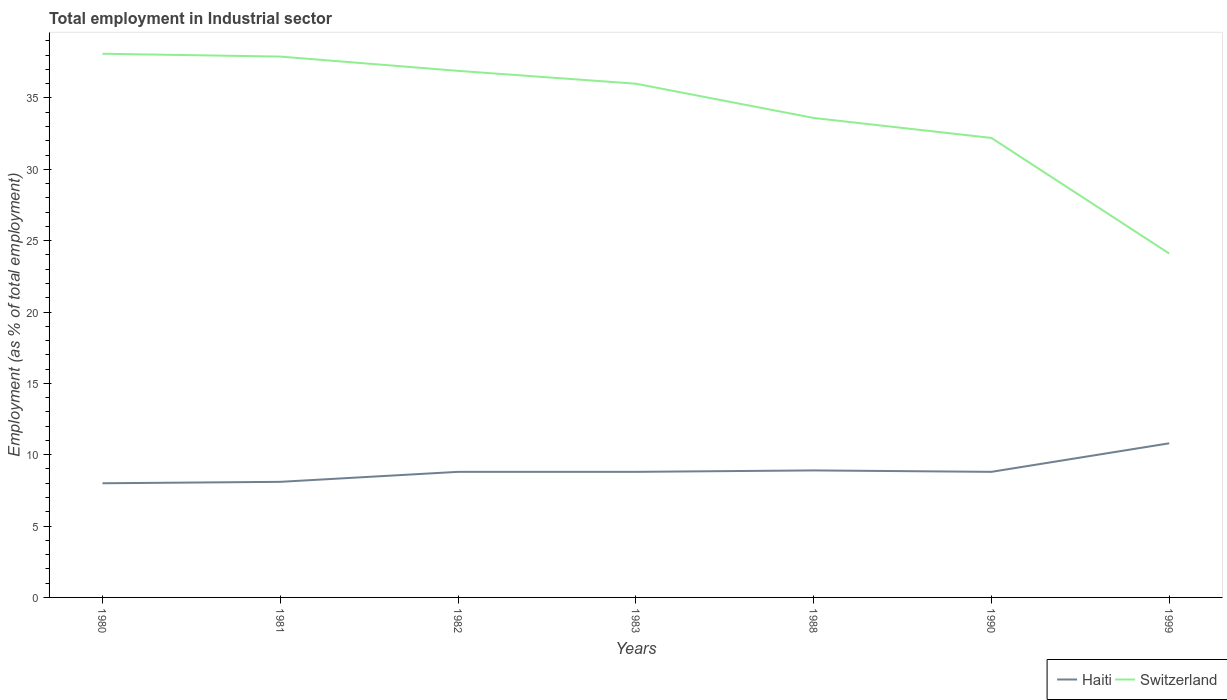Does the line corresponding to Haiti intersect with the line corresponding to Switzerland?
Provide a succinct answer. No. Is the number of lines equal to the number of legend labels?
Offer a very short reply. Yes. Across all years, what is the maximum employment in industrial sector in Switzerland?
Provide a succinct answer. 24.1. In which year was the employment in industrial sector in Haiti maximum?
Provide a short and direct response. 1980. What is the total employment in industrial sector in Haiti in the graph?
Your response must be concise. -0.1. What is the difference between the highest and the second highest employment in industrial sector in Switzerland?
Offer a very short reply. 14. Is the employment in industrial sector in Switzerland strictly greater than the employment in industrial sector in Haiti over the years?
Offer a very short reply. No. How many years are there in the graph?
Your answer should be very brief. 7. Does the graph contain any zero values?
Keep it short and to the point. No. Does the graph contain grids?
Provide a succinct answer. No. How many legend labels are there?
Your answer should be very brief. 2. What is the title of the graph?
Give a very brief answer. Total employment in Industrial sector. Does "Cameroon" appear as one of the legend labels in the graph?
Offer a terse response. No. What is the label or title of the X-axis?
Your answer should be very brief. Years. What is the label or title of the Y-axis?
Offer a very short reply. Employment (as % of total employment). What is the Employment (as % of total employment) of Haiti in 1980?
Keep it short and to the point. 8. What is the Employment (as % of total employment) in Switzerland in 1980?
Your answer should be very brief. 38.1. What is the Employment (as % of total employment) in Haiti in 1981?
Your response must be concise. 8.1. What is the Employment (as % of total employment) in Switzerland in 1981?
Offer a terse response. 37.9. What is the Employment (as % of total employment) of Haiti in 1982?
Give a very brief answer. 8.8. What is the Employment (as % of total employment) in Switzerland in 1982?
Your answer should be compact. 36.9. What is the Employment (as % of total employment) in Haiti in 1983?
Provide a short and direct response. 8.8. What is the Employment (as % of total employment) of Haiti in 1988?
Your response must be concise. 8.9. What is the Employment (as % of total employment) of Switzerland in 1988?
Offer a terse response. 33.6. What is the Employment (as % of total employment) of Haiti in 1990?
Keep it short and to the point. 8.8. What is the Employment (as % of total employment) of Switzerland in 1990?
Give a very brief answer. 32.2. What is the Employment (as % of total employment) of Haiti in 1999?
Offer a terse response. 10.8. What is the Employment (as % of total employment) of Switzerland in 1999?
Provide a short and direct response. 24.1. Across all years, what is the maximum Employment (as % of total employment) in Haiti?
Keep it short and to the point. 10.8. Across all years, what is the maximum Employment (as % of total employment) in Switzerland?
Provide a succinct answer. 38.1. Across all years, what is the minimum Employment (as % of total employment) in Switzerland?
Provide a succinct answer. 24.1. What is the total Employment (as % of total employment) in Haiti in the graph?
Provide a succinct answer. 62.2. What is the total Employment (as % of total employment) in Switzerland in the graph?
Keep it short and to the point. 238.8. What is the difference between the Employment (as % of total employment) in Haiti in 1980 and that in 1983?
Give a very brief answer. -0.8. What is the difference between the Employment (as % of total employment) of Haiti in 1980 and that in 1990?
Provide a short and direct response. -0.8. What is the difference between the Employment (as % of total employment) of Haiti in 1980 and that in 1999?
Provide a short and direct response. -2.8. What is the difference between the Employment (as % of total employment) of Haiti in 1981 and that in 1982?
Make the answer very short. -0.7. What is the difference between the Employment (as % of total employment) in Switzerland in 1981 and that in 1983?
Provide a short and direct response. 1.9. What is the difference between the Employment (as % of total employment) of Haiti in 1981 and that in 1988?
Provide a succinct answer. -0.8. What is the difference between the Employment (as % of total employment) in Switzerland in 1981 and that in 1999?
Your answer should be very brief. 13.8. What is the difference between the Employment (as % of total employment) of Haiti in 1982 and that in 1983?
Your response must be concise. 0. What is the difference between the Employment (as % of total employment) of Switzerland in 1982 and that in 1983?
Your answer should be compact. 0.9. What is the difference between the Employment (as % of total employment) of Switzerland in 1982 and that in 1988?
Your answer should be compact. 3.3. What is the difference between the Employment (as % of total employment) in Haiti in 1982 and that in 1990?
Provide a succinct answer. 0. What is the difference between the Employment (as % of total employment) in Switzerland in 1982 and that in 1990?
Your response must be concise. 4.7. What is the difference between the Employment (as % of total employment) in Switzerland in 1982 and that in 1999?
Provide a succinct answer. 12.8. What is the difference between the Employment (as % of total employment) of Haiti in 1983 and that in 1988?
Give a very brief answer. -0.1. What is the difference between the Employment (as % of total employment) of Switzerland in 1983 and that in 1988?
Provide a short and direct response. 2.4. What is the difference between the Employment (as % of total employment) of Haiti in 1983 and that in 1990?
Give a very brief answer. 0. What is the difference between the Employment (as % of total employment) in Haiti in 1983 and that in 1999?
Offer a terse response. -2. What is the difference between the Employment (as % of total employment) in Switzerland in 1988 and that in 1990?
Give a very brief answer. 1.4. What is the difference between the Employment (as % of total employment) in Haiti in 1988 and that in 1999?
Keep it short and to the point. -1.9. What is the difference between the Employment (as % of total employment) in Switzerland in 1990 and that in 1999?
Ensure brevity in your answer.  8.1. What is the difference between the Employment (as % of total employment) in Haiti in 1980 and the Employment (as % of total employment) in Switzerland in 1981?
Provide a short and direct response. -29.9. What is the difference between the Employment (as % of total employment) in Haiti in 1980 and the Employment (as % of total employment) in Switzerland in 1982?
Offer a terse response. -28.9. What is the difference between the Employment (as % of total employment) in Haiti in 1980 and the Employment (as % of total employment) in Switzerland in 1983?
Make the answer very short. -28. What is the difference between the Employment (as % of total employment) in Haiti in 1980 and the Employment (as % of total employment) in Switzerland in 1988?
Provide a succinct answer. -25.6. What is the difference between the Employment (as % of total employment) of Haiti in 1980 and the Employment (as % of total employment) of Switzerland in 1990?
Offer a terse response. -24.2. What is the difference between the Employment (as % of total employment) in Haiti in 1980 and the Employment (as % of total employment) in Switzerland in 1999?
Provide a short and direct response. -16.1. What is the difference between the Employment (as % of total employment) in Haiti in 1981 and the Employment (as % of total employment) in Switzerland in 1982?
Provide a short and direct response. -28.8. What is the difference between the Employment (as % of total employment) in Haiti in 1981 and the Employment (as % of total employment) in Switzerland in 1983?
Your response must be concise. -27.9. What is the difference between the Employment (as % of total employment) in Haiti in 1981 and the Employment (as % of total employment) in Switzerland in 1988?
Provide a succinct answer. -25.5. What is the difference between the Employment (as % of total employment) in Haiti in 1981 and the Employment (as % of total employment) in Switzerland in 1990?
Make the answer very short. -24.1. What is the difference between the Employment (as % of total employment) in Haiti in 1981 and the Employment (as % of total employment) in Switzerland in 1999?
Give a very brief answer. -16. What is the difference between the Employment (as % of total employment) in Haiti in 1982 and the Employment (as % of total employment) in Switzerland in 1983?
Offer a very short reply. -27.2. What is the difference between the Employment (as % of total employment) of Haiti in 1982 and the Employment (as % of total employment) of Switzerland in 1988?
Your answer should be very brief. -24.8. What is the difference between the Employment (as % of total employment) in Haiti in 1982 and the Employment (as % of total employment) in Switzerland in 1990?
Provide a short and direct response. -23.4. What is the difference between the Employment (as % of total employment) of Haiti in 1982 and the Employment (as % of total employment) of Switzerland in 1999?
Your response must be concise. -15.3. What is the difference between the Employment (as % of total employment) of Haiti in 1983 and the Employment (as % of total employment) of Switzerland in 1988?
Offer a very short reply. -24.8. What is the difference between the Employment (as % of total employment) in Haiti in 1983 and the Employment (as % of total employment) in Switzerland in 1990?
Your answer should be compact. -23.4. What is the difference between the Employment (as % of total employment) in Haiti in 1983 and the Employment (as % of total employment) in Switzerland in 1999?
Ensure brevity in your answer.  -15.3. What is the difference between the Employment (as % of total employment) of Haiti in 1988 and the Employment (as % of total employment) of Switzerland in 1990?
Provide a short and direct response. -23.3. What is the difference between the Employment (as % of total employment) in Haiti in 1988 and the Employment (as % of total employment) in Switzerland in 1999?
Provide a short and direct response. -15.2. What is the difference between the Employment (as % of total employment) of Haiti in 1990 and the Employment (as % of total employment) of Switzerland in 1999?
Your response must be concise. -15.3. What is the average Employment (as % of total employment) in Haiti per year?
Offer a terse response. 8.89. What is the average Employment (as % of total employment) in Switzerland per year?
Provide a succinct answer. 34.11. In the year 1980, what is the difference between the Employment (as % of total employment) in Haiti and Employment (as % of total employment) in Switzerland?
Your response must be concise. -30.1. In the year 1981, what is the difference between the Employment (as % of total employment) of Haiti and Employment (as % of total employment) of Switzerland?
Keep it short and to the point. -29.8. In the year 1982, what is the difference between the Employment (as % of total employment) of Haiti and Employment (as % of total employment) of Switzerland?
Offer a very short reply. -28.1. In the year 1983, what is the difference between the Employment (as % of total employment) in Haiti and Employment (as % of total employment) in Switzerland?
Give a very brief answer. -27.2. In the year 1988, what is the difference between the Employment (as % of total employment) of Haiti and Employment (as % of total employment) of Switzerland?
Offer a terse response. -24.7. In the year 1990, what is the difference between the Employment (as % of total employment) of Haiti and Employment (as % of total employment) of Switzerland?
Ensure brevity in your answer.  -23.4. What is the ratio of the Employment (as % of total employment) of Switzerland in 1980 to that in 1981?
Your answer should be compact. 1.01. What is the ratio of the Employment (as % of total employment) of Switzerland in 1980 to that in 1982?
Provide a short and direct response. 1.03. What is the ratio of the Employment (as % of total employment) of Switzerland in 1980 to that in 1983?
Give a very brief answer. 1.06. What is the ratio of the Employment (as % of total employment) of Haiti in 1980 to that in 1988?
Provide a succinct answer. 0.9. What is the ratio of the Employment (as % of total employment) of Switzerland in 1980 to that in 1988?
Provide a short and direct response. 1.13. What is the ratio of the Employment (as % of total employment) of Switzerland in 1980 to that in 1990?
Keep it short and to the point. 1.18. What is the ratio of the Employment (as % of total employment) in Haiti in 1980 to that in 1999?
Your response must be concise. 0.74. What is the ratio of the Employment (as % of total employment) in Switzerland in 1980 to that in 1999?
Your answer should be compact. 1.58. What is the ratio of the Employment (as % of total employment) of Haiti in 1981 to that in 1982?
Ensure brevity in your answer.  0.92. What is the ratio of the Employment (as % of total employment) of Switzerland in 1981 to that in 1982?
Provide a short and direct response. 1.03. What is the ratio of the Employment (as % of total employment) in Haiti in 1981 to that in 1983?
Ensure brevity in your answer.  0.92. What is the ratio of the Employment (as % of total employment) of Switzerland in 1981 to that in 1983?
Make the answer very short. 1.05. What is the ratio of the Employment (as % of total employment) in Haiti in 1981 to that in 1988?
Offer a terse response. 0.91. What is the ratio of the Employment (as % of total employment) of Switzerland in 1981 to that in 1988?
Give a very brief answer. 1.13. What is the ratio of the Employment (as % of total employment) of Haiti in 1981 to that in 1990?
Ensure brevity in your answer.  0.92. What is the ratio of the Employment (as % of total employment) in Switzerland in 1981 to that in 1990?
Provide a short and direct response. 1.18. What is the ratio of the Employment (as % of total employment) of Switzerland in 1981 to that in 1999?
Provide a short and direct response. 1.57. What is the ratio of the Employment (as % of total employment) of Haiti in 1982 to that in 1983?
Your answer should be compact. 1. What is the ratio of the Employment (as % of total employment) of Haiti in 1982 to that in 1988?
Offer a terse response. 0.99. What is the ratio of the Employment (as % of total employment) of Switzerland in 1982 to that in 1988?
Your answer should be compact. 1.1. What is the ratio of the Employment (as % of total employment) in Switzerland in 1982 to that in 1990?
Provide a short and direct response. 1.15. What is the ratio of the Employment (as % of total employment) of Haiti in 1982 to that in 1999?
Provide a short and direct response. 0.81. What is the ratio of the Employment (as % of total employment) of Switzerland in 1982 to that in 1999?
Make the answer very short. 1.53. What is the ratio of the Employment (as % of total employment) in Switzerland in 1983 to that in 1988?
Keep it short and to the point. 1.07. What is the ratio of the Employment (as % of total employment) of Haiti in 1983 to that in 1990?
Make the answer very short. 1. What is the ratio of the Employment (as % of total employment) in Switzerland in 1983 to that in 1990?
Provide a short and direct response. 1.12. What is the ratio of the Employment (as % of total employment) of Haiti in 1983 to that in 1999?
Offer a terse response. 0.81. What is the ratio of the Employment (as % of total employment) in Switzerland in 1983 to that in 1999?
Keep it short and to the point. 1.49. What is the ratio of the Employment (as % of total employment) of Haiti in 1988 to that in 1990?
Offer a very short reply. 1.01. What is the ratio of the Employment (as % of total employment) in Switzerland in 1988 to that in 1990?
Offer a terse response. 1.04. What is the ratio of the Employment (as % of total employment) of Haiti in 1988 to that in 1999?
Make the answer very short. 0.82. What is the ratio of the Employment (as % of total employment) of Switzerland in 1988 to that in 1999?
Keep it short and to the point. 1.39. What is the ratio of the Employment (as % of total employment) in Haiti in 1990 to that in 1999?
Provide a succinct answer. 0.81. What is the ratio of the Employment (as % of total employment) of Switzerland in 1990 to that in 1999?
Ensure brevity in your answer.  1.34. What is the difference between the highest and the second highest Employment (as % of total employment) of Haiti?
Your answer should be very brief. 1.9. What is the difference between the highest and the lowest Employment (as % of total employment) of Switzerland?
Ensure brevity in your answer.  14. 